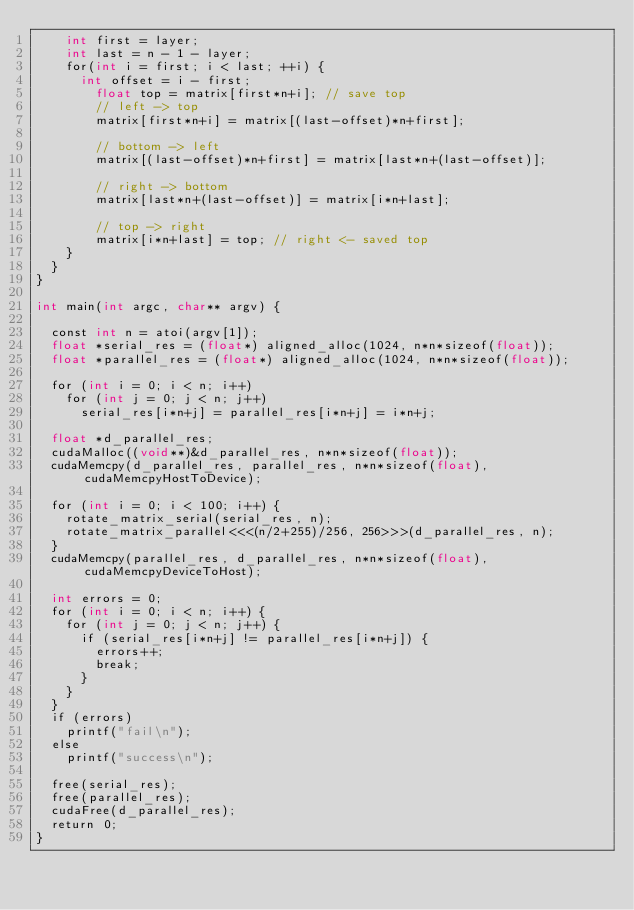<code> <loc_0><loc_0><loc_500><loc_500><_Cuda_>    int first = layer;
    int last = n - 1 - layer;
    for(int i = first; i < last; ++i) {
      int offset = i - first;
        float top = matrix[first*n+i]; // save top
        // left -> top
        matrix[first*n+i] = matrix[(last-offset)*n+first];

        // bottom -> left
        matrix[(last-offset)*n+first] = matrix[last*n+(last-offset)];

        // right -> bottom
        matrix[last*n+(last-offset)] = matrix[i*n+last];

        // top -> right
        matrix[i*n+last] = top; // right <- saved top
    }
  }
}

int main(int argc, char** argv) {

  const int n = atoi(argv[1]);
  float *serial_res = (float*) aligned_alloc(1024, n*n*sizeof(float));
  float *parallel_res = (float*) aligned_alloc(1024, n*n*sizeof(float));

  for (int i = 0; i < n; i++)
    for (int j = 0; j < n; j++)
      serial_res[i*n+j] = parallel_res[i*n+j] = i*n+j;

  float *d_parallel_res;
  cudaMalloc((void**)&d_parallel_res, n*n*sizeof(float));
  cudaMemcpy(d_parallel_res, parallel_res, n*n*sizeof(float), cudaMemcpyHostToDevice);

  for (int i = 0; i < 100; i++) {
    rotate_matrix_serial(serial_res, n);
    rotate_matrix_parallel<<<(n/2+255)/256, 256>>>(d_parallel_res, n);
  }
  cudaMemcpy(parallel_res, d_parallel_res, n*n*sizeof(float), cudaMemcpyDeviceToHost);

  int errors = 0;
  for (int i = 0; i < n; i++) {
    for (int j = 0; j < n; j++) {
      if (serial_res[i*n+j] != parallel_res[i*n+j]) {
        errors++; 
        break;
      }
    }
  }
  if (errors) 
    printf("fail\n");
  else 
    printf("success\n");

  free(serial_res);
  free(parallel_res);
  cudaFree(d_parallel_res);
  return 0;
}

</code> 